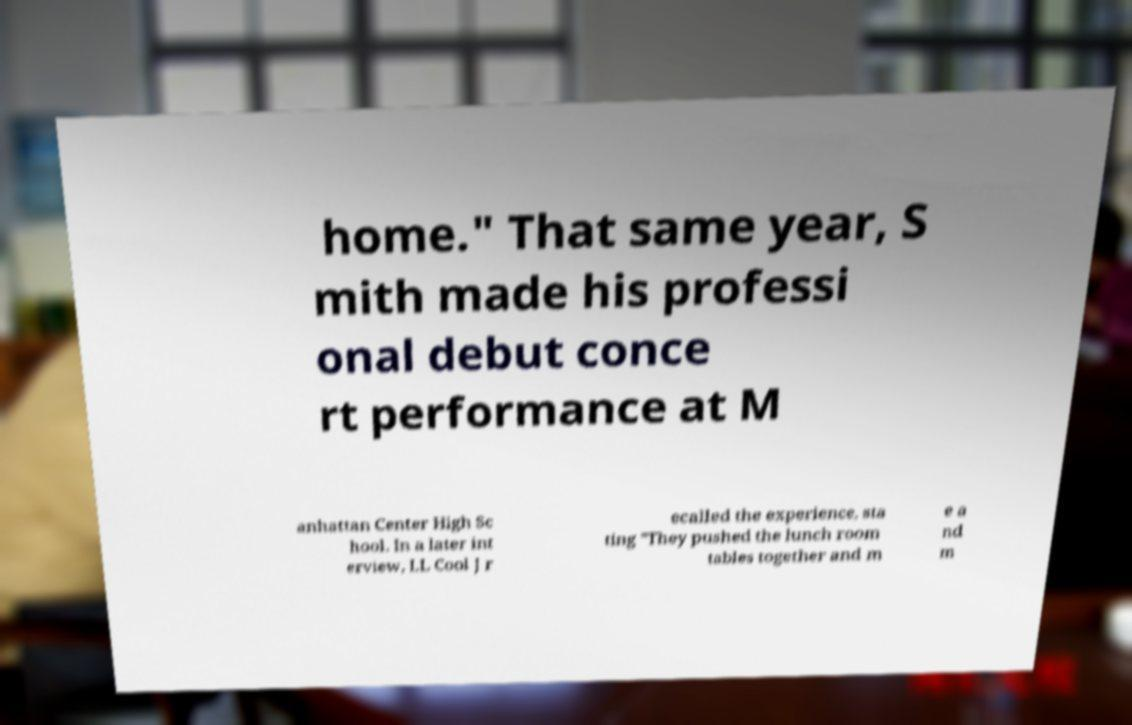Please read and relay the text visible in this image. What does it say? home." That same year, S mith made his professi onal debut conce rt performance at M anhattan Center High Sc hool. In a later int erview, LL Cool J r ecalled the experience, sta ting "They pushed the lunch room tables together and m e a nd m 